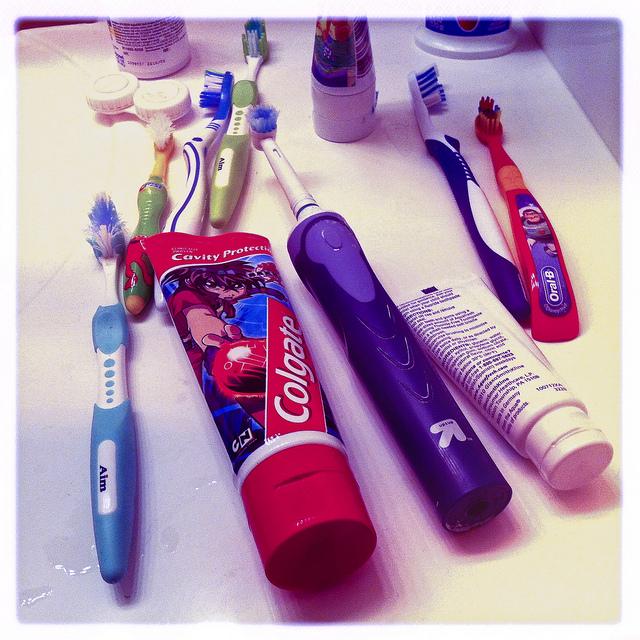What kind of toothpaste is in the photo?
Give a very brief answer. Colgate. How many kids are using this toothpaste?
Concise answer only. 2. How many toothbrushes are in this picture?
Keep it brief. 7. 